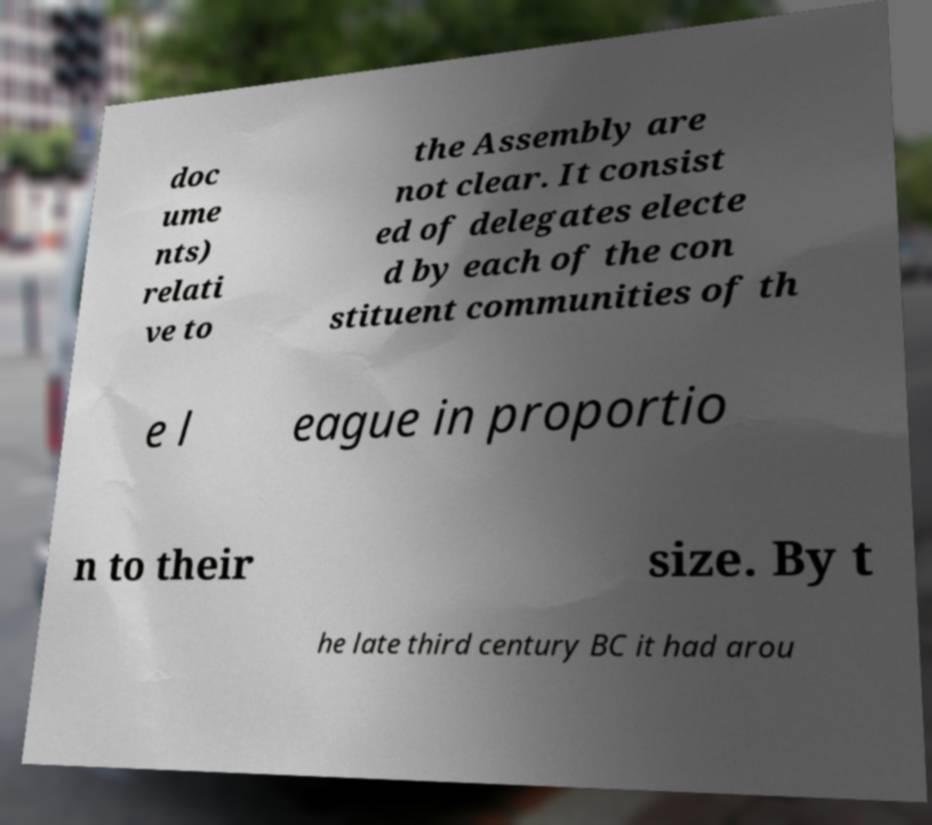For documentation purposes, I need the text within this image transcribed. Could you provide that? doc ume nts) relati ve to the Assembly are not clear. It consist ed of delegates electe d by each of the con stituent communities of th e l eague in proportio n to their size. By t he late third century BC it had arou 